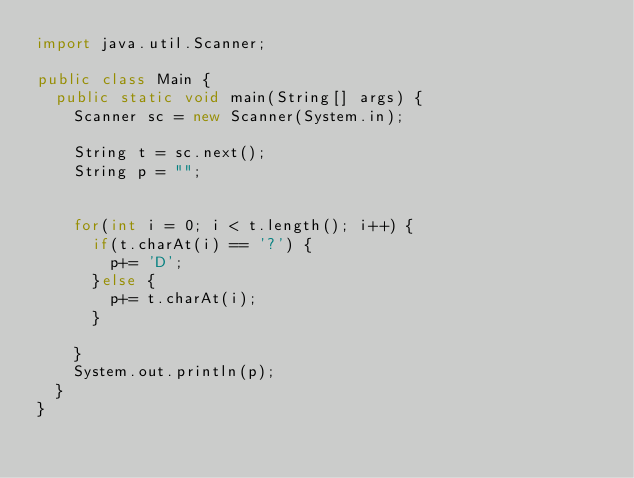<code> <loc_0><loc_0><loc_500><loc_500><_Java_>import java.util.Scanner;

public class Main {
	public static void main(String[] args) {
		Scanner sc = new Scanner(System.in);
		
		String t = sc.next();
		String p = "";
		
		
		for(int i = 0; i < t.length(); i++) {
			if(t.charAt(i) == '?') {
				p+= 'D';
			}else {
				p+= t.charAt(i);
			}
	
		}
		System.out.println(p);
	}
}
</code> 